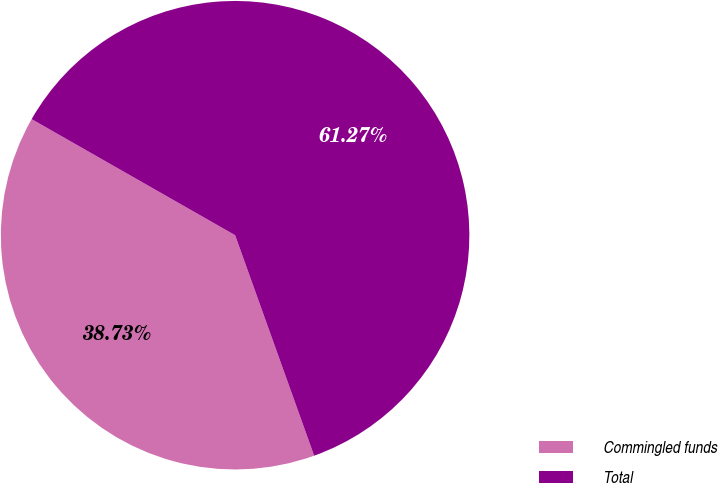Convert chart. <chart><loc_0><loc_0><loc_500><loc_500><pie_chart><fcel>Commingled funds<fcel>Total<nl><fcel>38.73%<fcel>61.27%<nl></chart> 